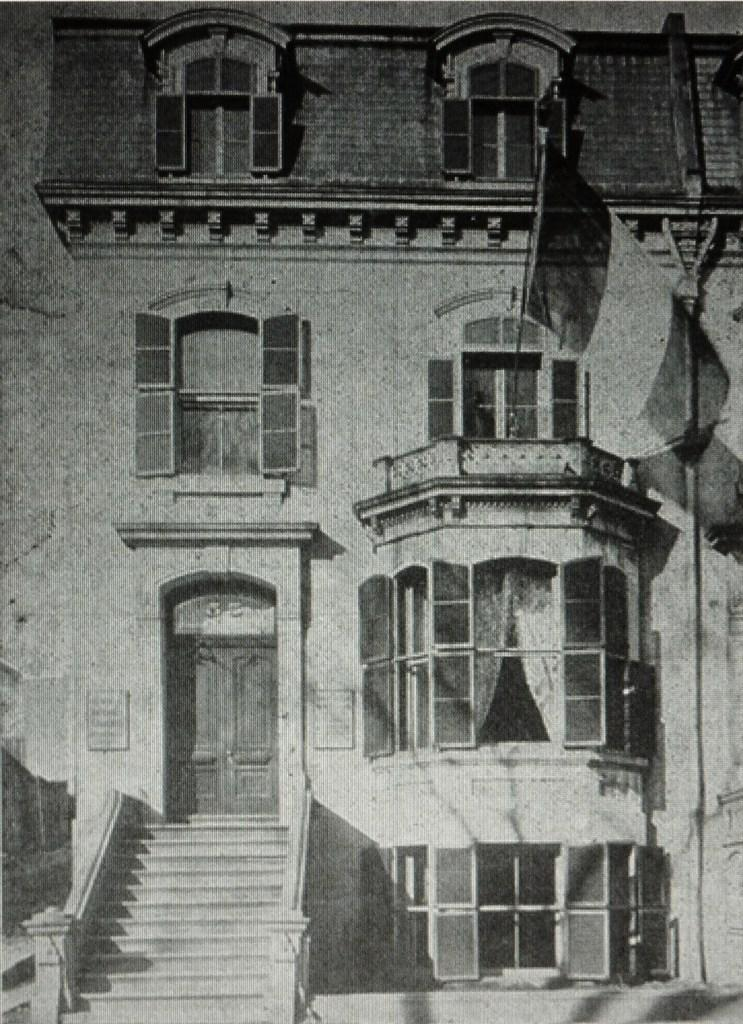What is the color scheme of the image? The image is black and white. What structure can be seen in the image? There is a building in the image. What features are present on the building? The building has doors and windows. Where are the stairs located in the image? The stairs are on the left side of the building in the image. Can you tell me how many shelves are present in the image? There are no shelves visible in the image. What type of laborer is working on the building in the image? There are no laborers present in the image; it only shows the building with doors, windows, and stairs. 